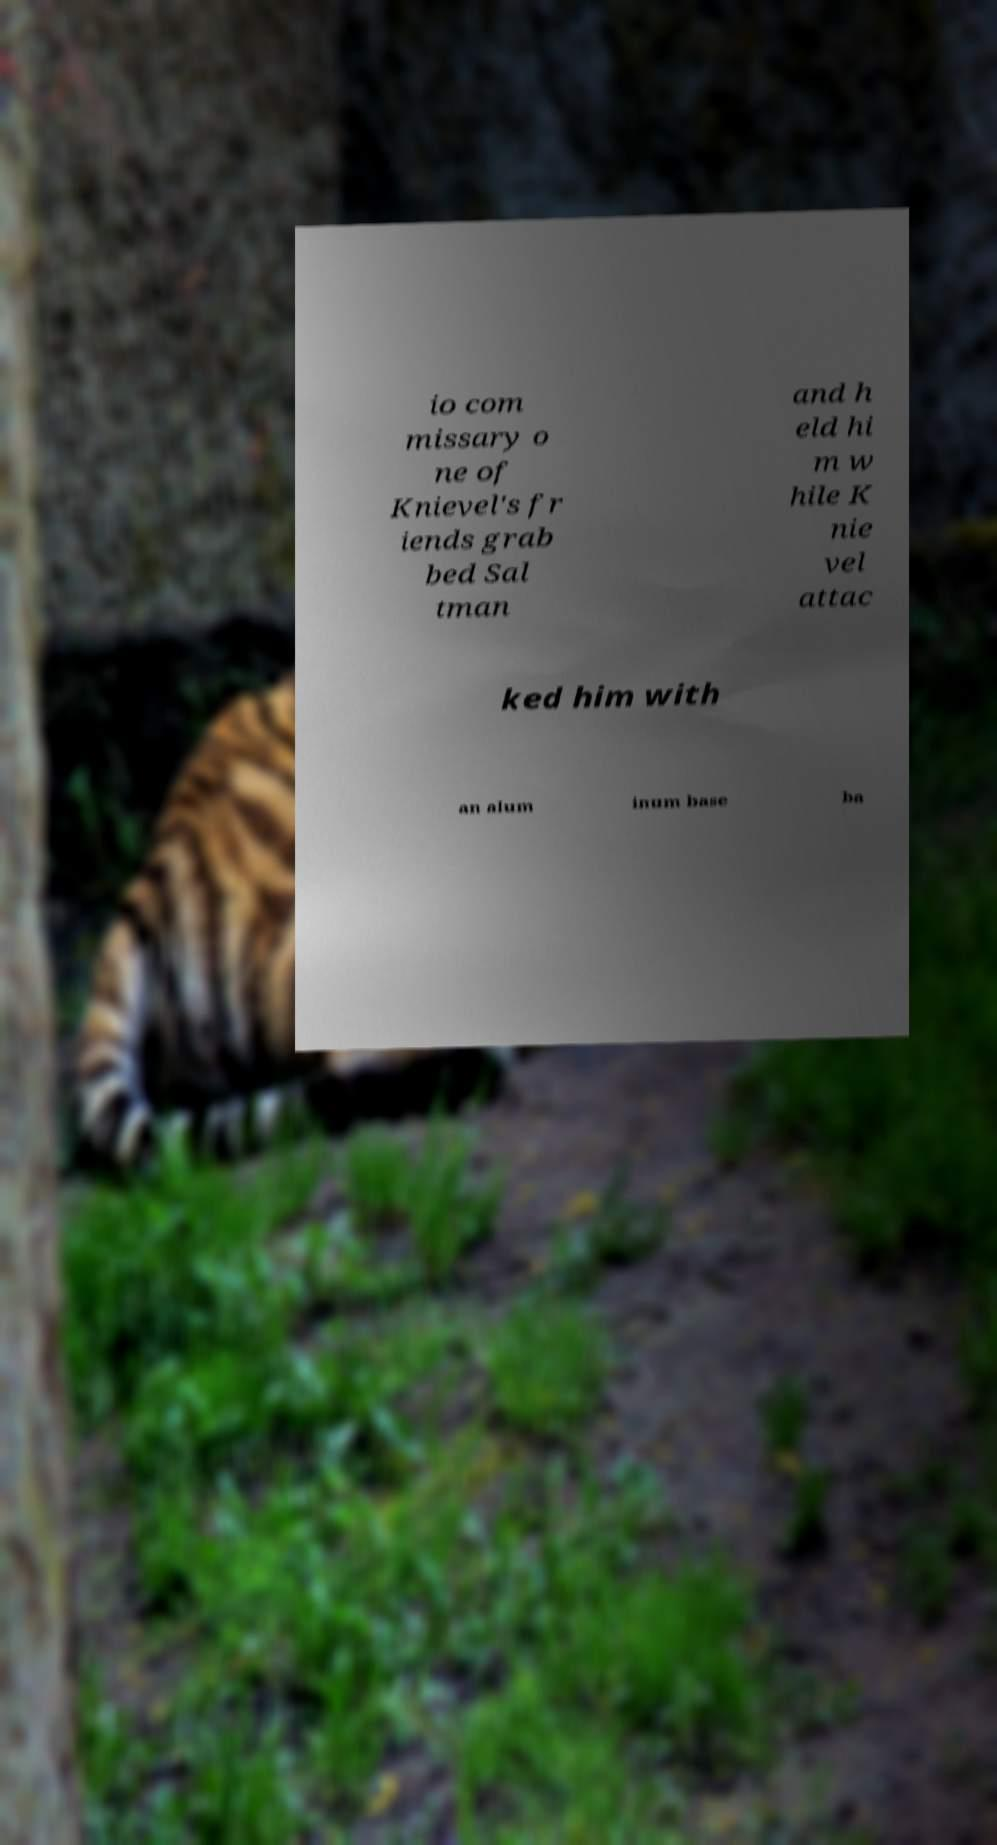There's text embedded in this image that I need extracted. Can you transcribe it verbatim? io com missary o ne of Knievel's fr iends grab bed Sal tman and h eld hi m w hile K nie vel attac ked him with an alum inum base ba 